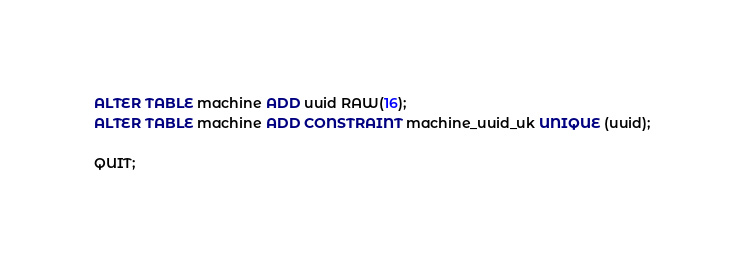Convert code to text. <code><loc_0><loc_0><loc_500><loc_500><_SQL_>ALTER TABLE machine ADD uuid RAW(16);
ALTER TABLE machine ADD CONSTRAINT machine_uuid_uk UNIQUE (uuid);

QUIT;
</code> 